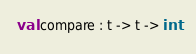<code> <loc_0><loc_0><loc_500><loc_500><_OCaml_>
val compare : t -> t -> int
</code> 